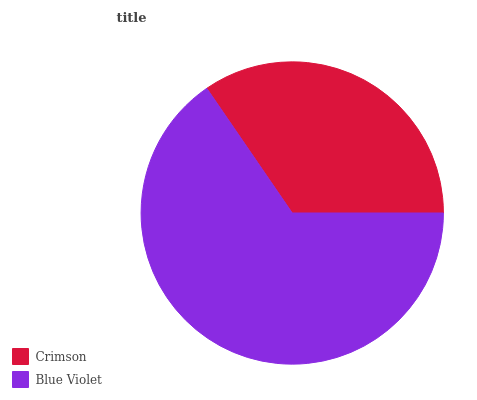Is Crimson the minimum?
Answer yes or no. Yes. Is Blue Violet the maximum?
Answer yes or no. Yes. Is Blue Violet the minimum?
Answer yes or no. No. Is Blue Violet greater than Crimson?
Answer yes or no. Yes. Is Crimson less than Blue Violet?
Answer yes or no. Yes. Is Crimson greater than Blue Violet?
Answer yes or no. No. Is Blue Violet less than Crimson?
Answer yes or no. No. Is Blue Violet the high median?
Answer yes or no. Yes. Is Crimson the low median?
Answer yes or no. Yes. Is Crimson the high median?
Answer yes or no. No. Is Blue Violet the low median?
Answer yes or no. No. 